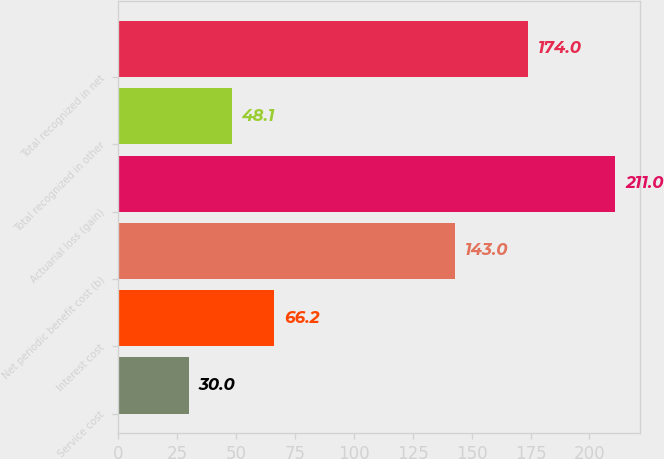Convert chart. <chart><loc_0><loc_0><loc_500><loc_500><bar_chart><fcel>Service cost<fcel>Interest cost<fcel>Net periodic benefit cost (b)<fcel>Actuarial loss (gain)<fcel>Total recognized in other<fcel>Total recognized in net<nl><fcel>30<fcel>66.2<fcel>143<fcel>211<fcel>48.1<fcel>174<nl></chart> 